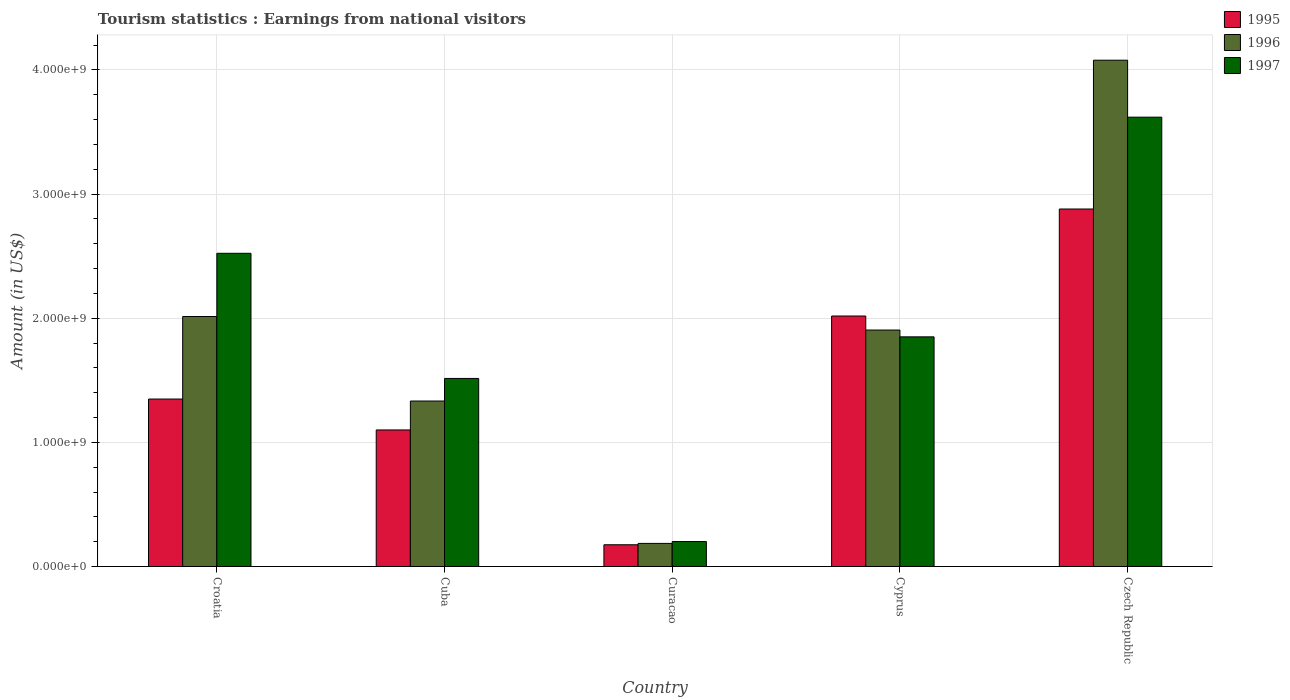How many groups of bars are there?
Your answer should be very brief. 5. Are the number of bars per tick equal to the number of legend labels?
Keep it short and to the point. Yes. How many bars are there on the 2nd tick from the right?
Make the answer very short. 3. What is the label of the 2nd group of bars from the left?
Your response must be concise. Cuba. What is the earnings from national visitors in 1997 in Croatia?
Your response must be concise. 2.52e+09. Across all countries, what is the maximum earnings from national visitors in 1997?
Keep it short and to the point. 3.62e+09. Across all countries, what is the minimum earnings from national visitors in 1996?
Offer a very short reply. 1.86e+08. In which country was the earnings from national visitors in 1995 maximum?
Ensure brevity in your answer.  Czech Republic. In which country was the earnings from national visitors in 1996 minimum?
Offer a very short reply. Curacao. What is the total earnings from national visitors in 1996 in the graph?
Offer a terse response. 9.52e+09. What is the difference between the earnings from national visitors in 1997 in Cuba and that in Cyprus?
Offer a terse response. -3.35e+08. What is the difference between the earnings from national visitors in 1997 in Cyprus and the earnings from national visitors in 1995 in Croatia?
Provide a succinct answer. 5.01e+08. What is the average earnings from national visitors in 1997 per country?
Give a very brief answer. 1.94e+09. What is the difference between the earnings from national visitors of/in 1997 and earnings from national visitors of/in 1996 in Cyprus?
Make the answer very short. -5.50e+07. What is the ratio of the earnings from national visitors in 1995 in Curacao to that in Czech Republic?
Provide a succinct answer. 0.06. Is the earnings from national visitors in 1995 in Croatia less than that in Cyprus?
Provide a succinct answer. Yes. What is the difference between the highest and the second highest earnings from national visitors in 1997?
Offer a very short reply. 1.10e+09. What is the difference between the highest and the lowest earnings from national visitors in 1996?
Give a very brief answer. 3.89e+09. In how many countries, is the earnings from national visitors in 1996 greater than the average earnings from national visitors in 1996 taken over all countries?
Your answer should be compact. 3. Is the sum of the earnings from national visitors in 1997 in Curacao and Cyprus greater than the maximum earnings from national visitors in 1995 across all countries?
Ensure brevity in your answer.  No. What does the 2nd bar from the left in Cuba represents?
Your response must be concise. 1996. What does the 1st bar from the right in Cyprus represents?
Keep it short and to the point. 1997. How many bars are there?
Your answer should be very brief. 15. How many countries are there in the graph?
Offer a very short reply. 5. How many legend labels are there?
Provide a short and direct response. 3. What is the title of the graph?
Your answer should be compact. Tourism statistics : Earnings from national visitors. What is the label or title of the X-axis?
Offer a very short reply. Country. What is the Amount (in US$) of 1995 in Croatia?
Make the answer very short. 1.35e+09. What is the Amount (in US$) of 1996 in Croatia?
Provide a succinct answer. 2.01e+09. What is the Amount (in US$) in 1997 in Croatia?
Your answer should be very brief. 2.52e+09. What is the Amount (in US$) in 1995 in Cuba?
Make the answer very short. 1.10e+09. What is the Amount (in US$) of 1996 in Cuba?
Ensure brevity in your answer.  1.33e+09. What is the Amount (in US$) of 1997 in Cuba?
Keep it short and to the point. 1.52e+09. What is the Amount (in US$) in 1995 in Curacao?
Your answer should be very brief. 1.75e+08. What is the Amount (in US$) in 1996 in Curacao?
Your answer should be compact. 1.86e+08. What is the Amount (in US$) in 1997 in Curacao?
Make the answer very short. 2.01e+08. What is the Amount (in US$) of 1995 in Cyprus?
Ensure brevity in your answer.  2.02e+09. What is the Amount (in US$) in 1996 in Cyprus?
Keep it short and to the point. 1.90e+09. What is the Amount (in US$) of 1997 in Cyprus?
Ensure brevity in your answer.  1.85e+09. What is the Amount (in US$) of 1995 in Czech Republic?
Keep it short and to the point. 2.88e+09. What is the Amount (in US$) of 1996 in Czech Republic?
Give a very brief answer. 4.08e+09. What is the Amount (in US$) in 1997 in Czech Republic?
Provide a succinct answer. 3.62e+09. Across all countries, what is the maximum Amount (in US$) of 1995?
Your answer should be very brief. 2.88e+09. Across all countries, what is the maximum Amount (in US$) of 1996?
Your answer should be compact. 4.08e+09. Across all countries, what is the maximum Amount (in US$) of 1997?
Offer a very short reply. 3.62e+09. Across all countries, what is the minimum Amount (in US$) of 1995?
Give a very brief answer. 1.75e+08. Across all countries, what is the minimum Amount (in US$) of 1996?
Offer a very short reply. 1.86e+08. Across all countries, what is the minimum Amount (in US$) in 1997?
Your response must be concise. 2.01e+08. What is the total Amount (in US$) of 1995 in the graph?
Make the answer very short. 7.52e+09. What is the total Amount (in US$) in 1996 in the graph?
Provide a succinct answer. 9.52e+09. What is the total Amount (in US$) of 1997 in the graph?
Your answer should be compact. 9.71e+09. What is the difference between the Amount (in US$) in 1995 in Croatia and that in Cuba?
Your answer should be compact. 2.49e+08. What is the difference between the Amount (in US$) of 1996 in Croatia and that in Cuba?
Give a very brief answer. 6.81e+08. What is the difference between the Amount (in US$) of 1997 in Croatia and that in Cuba?
Provide a succinct answer. 1.01e+09. What is the difference between the Amount (in US$) in 1995 in Croatia and that in Curacao?
Ensure brevity in your answer.  1.17e+09. What is the difference between the Amount (in US$) in 1996 in Croatia and that in Curacao?
Make the answer very short. 1.83e+09. What is the difference between the Amount (in US$) in 1997 in Croatia and that in Curacao?
Your answer should be compact. 2.32e+09. What is the difference between the Amount (in US$) of 1995 in Croatia and that in Cyprus?
Provide a short and direct response. -6.69e+08. What is the difference between the Amount (in US$) of 1996 in Croatia and that in Cyprus?
Offer a very short reply. 1.09e+08. What is the difference between the Amount (in US$) in 1997 in Croatia and that in Cyprus?
Your response must be concise. 6.73e+08. What is the difference between the Amount (in US$) of 1995 in Croatia and that in Czech Republic?
Your answer should be compact. -1.53e+09. What is the difference between the Amount (in US$) of 1996 in Croatia and that in Czech Republic?
Ensure brevity in your answer.  -2.06e+09. What is the difference between the Amount (in US$) in 1997 in Croatia and that in Czech Republic?
Give a very brief answer. -1.10e+09. What is the difference between the Amount (in US$) in 1995 in Cuba and that in Curacao?
Provide a succinct answer. 9.25e+08. What is the difference between the Amount (in US$) in 1996 in Cuba and that in Curacao?
Make the answer very short. 1.15e+09. What is the difference between the Amount (in US$) of 1997 in Cuba and that in Curacao?
Offer a very short reply. 1.31e+09. What is the difference between the Amount (in US$) of 1995 in Cuba and that in Cyprus?
Ensure brevity in your answer.  -9.18e+08. What is the difference between the Amount (in US$) of 1996 in Cuba and that in Cyprus?
Offer a terse response. -5.72e+08. What is the difference between the Amount (in US$) in 1997 in Cuba and that in Cyprus?
Offer a very short reply. -3.35e+08. What is the difference between the Amount (in US$) in 1995 in Cuba and that in Czech Republic?
Give a very brief answer. -1.78e+09. What is the difference between the Amount (in US$) in 1996 in Cuba and that in Czech Republic?
Ensure brevity in your answer.  -2.75e+09. What is the difference between the Amount (in US$) of 1997 in Cuba and that in Czech Republic?
Offer a very short reply. -2.10e+09. What is the difference between the Amount (in US$) of 1995 in Curacao and that in Cyprus?
Your response must be concise. -1.84e+09. What is the difference between the Amount (in US$) of 1996 in Curacao and that in Cyprus?
Your response must be concise. -1.72e+09. What is the difference between the Amount (in US$) in 1997 in Curacao and that in Cyprus?
Make the answer very short. -1.65e+09. What is the difference between the Amount (in US$) in 1995 in Curacao and that in Czech Republic?
Provide a short and direct response. -2.70e+09. What is the difference between the Amount (in US$) in 1996 in Curacao and that in Czech Republic?
Your response must be concise. -3.89e+09. What is the difference between the Amount (in US$) in 1997 in Curacao and that in Czech Republic?
Your response must be concise. -3.42e+09. What is the difference between the Amount (in US$) in 1995 in Cyprus and that in Czech Republic?
Your answer should be very brief. -8.62e+08. What is the difference between the Amount (in US$) of 1996 in Cyprus and that in Czech Republic?
Give a very brief answer. -2.17e+09. What is the difference between the Amount (in US$) of 1997 in Cyprus and that in Czech Republic?
Offer a very short reply. -1.77e+09. What is the difference between the Amount (in US$) in 1995 in Croatia and the Amount (in US$) in 1996 in Cuba?
Give a very brief answer. 1.60e+07. What is the difference between the Amount (in US$) of 1995 in Croatia and the Amount (in US$) of 1997 in Cuba?
Make the answer very short. -1.66e+08. What is the difference between the Amount (in US$) in 1996 in Croatia and the Amount (in US$) in 1997 in Cuba?
Provide a succinct answer. 4.99e+08. What is the difference between the Amount (in US$) of 1995 in Croatia and the Amount (in US$) of 1996 in Curacao?
Your response must be concise. 1.16e+09. What is the difference between the Amount (in US$) in 1995 in Croatia and the Amount (in US$) in 1997 in Curacao?
Your answer should be very brief. 1.15e+09. What is the difference between the Amount (in US$) of 1996 in Croatia and the Amount (in US$) of 1997 in Curacao?
Offer a terse response. 1.81e+09. What is the difference between the Amount (in US$) in 1995 in Croatia and the Amount (in US$) in 1996 in Cyprus?
Your answer should be compact. -5.56e+08. What is the difference between the Amount (in US$) in 1995 in Croatia and the Amount (in US$) in 1997 in Cyprus?
Give a very brief answer. -5.01e+08. What is the difference between the Amount (in US$) in 1996 in Croatia and the Amount (in US$) in 1997 in Cyprus?
Keep it short and to the point. 1.64e+08. What is the difference between the Amount (in US$) of 1995 in Croatia and the Amount (in US$) of 1996 in Czech Republic?
Your answer should be compact. -2.73e+09. What is the difference between the Amount (in US$) in 1995 in Croatia and the Amount (in US$) in 1997 in Czech Republic?
Ensure brevity in your answer.  -2.27e+09. What is the difference between the Amount (in US$) of 1996 in Croatia and the Amount (in US$) of 1997 in Czech Republic?
Offer a terse response. -1.61e+09. What is the difference between the Amount (in US$) in 1995 in Cuba and the Amount (in US$) in 1996 in Curacao?
Provide a short and direct response. 9.14e+08. What is the difference between the Amount (in US$) of 1995 in Cuba and the Amount (in US$) of 1997 in Curacao?
Provide a short and direct response. 8.99e+08. What is the difference between the Amount (in US$) in 1996 in Cuba and the Amount (in US$) in 1997 in Curacao?
Your answer should be compact. 1.13e+09. What is the difference between the Amount (in US$) in 1995 in Cuba and the Amount (in US$) in 1996 in Cyprus?
Ensure brevity in your answer.  -8.05e+08. What is the difference between the Amount (in US$) in 1995 in Cuba and the Amount (in US$) in 1997 in Cyprus?
Provide a succinct answer. -7.50e+08. What is the difference between the Amount (in US$) in 1996 in Cuba and the Amount (in US$) in 1997 in Cyprus?
Give a very brief answer. -5.17e+08. What is the difference between the Amount (in US$) of 1995 in Cuba and the Amount (in US$) of 1996 in Czech Republic?
Ensure brevity in your answer.  -2.98e+09. What is the difference between the Amount (in US$) in 1995 in Cuba and the Amount (in US$) in 1997 in Czech Republic?
Keep it short and to the point. -2.52e+09. What is the difference between the Amount (in US$) of 1996 in Cuba and the Amount (in US$) of 1997 in Czech Republic?
Give a very brief answer. -2.29e+09. What is the difference between the Amount (in US$) in 1995 in Curacao and the Amount (in US$) in 1996 in Cyprus?
Give a very brief answer. -1.73e+09. What is the difference between the Amount (in US$) in 1995 in Curacao and the Amount (in US$) in 1997 in Cyprus?
Your response must be concise. -1.68e+09. What is the difference between the Amount (in US$) in 1996 in Curacao and the Amount (in US$) in 1997 in Cyprus?
Your answer should be compact. -1.66e+09. What is the difference between the Amount (in US$) in 1995 in Curacao and the Amount (in US$) in 1996 in Czech Republic?
Your answer should be compact. -3.90e+09. What is the difference between the Amount (in US$) of 1995 in Curacao and the Amount (in US$) of 1997 in Czech Republic?
Give a very brief answer. -3.44e+09. What is the difference between the Amount (in US$) in 1996 in Curacao and the Amount (in US$) in 1997 in Czech Republic?
Offer a very short reply. -3.43e+09. What is the difference between the Amount (in US$) of 1995 in Cyprus and the Amount (in US$) of 1996 in Czech Republic?
Give a very brief answer. -2.06e+09. What is the difference between the Amount (in US$) of 1995 in Cyprus and the Amount (in US$) of 1997 in Czech Republic?
Provide a succinct answer. -1.60e+09. What is the difference between the Amount (in US$) in 1996 in Cyprus and the Amount (in US$) in 1997 in Czech Republic?
Provide a succinct answer. -1.72e+09. What is the average Amount (in US$) in 1995 per country?
Keep it short and to the point. 1.50e+09. What is the average Amount (in US$) in 1996 per country?
Provide a short and direct response. 1.90e+09. What is the average Amount (in US$) in 1997 per country?
Give a very brief answer. 1.94e+09. What is the difference between the Amount (in US$) of 1995 and Amount (in US$) of 1996 in Croatia?
Your answer should be compact. -6.65e+08. What is the difference between the Amount (in US$) in 1995 and Amount (in US$) in 1997 in Croatia?
Your answer should be compact. -1.17e+09. What is the difference between the Amount (in US$) in 1996 and Amount (in US$) in 1997 in Croatia?
Make the answer very short. -5.09e+08. What is the difference between the Amount (in US$) of 1995 and Amount (in US$) of 1996 in Cuba?
Keep it short and to the point. -2.33e+08. What is the difference between the Amount (in US$) of 1995 and Amount (in US$) of 1997 in Cuba?
Your answer should be compact. -4.15e+08. What is the difference between the Amount (in US$) of 1996 and Amount (in US$) of 1997 in Cuba?
Provide a short and direct response. -1.82e+08. What is the difference between the Amount (in US$) in 1995 and Amount (in US$) in 1996 in Curacao?
Offer a very short reply. -1.10e+07. What is the difference between the Amount (in US$) in 1995 and Amount (in US$) in 1997 in Curacao?
Give a very brief answer. -2.60e+07. What is the difference between the Amount (in US$) of 1996 and Amount (in US$) of 1997 in Curacao?
Keep it short and to the point. -1.50e+07. What is the difference between the Amount (in US$) in 1995 and Amount (in US$) in 1996 in Cyprus?
Your answer should be compact. 1.13e+08. What is the difference between the Amount (in US$) of 1995 and Amount (in US$) of 1997 in Cyprus?
Your response must be concise. 1.68e+08. What is the difference between the Amount (in US$) in 1996 and Amount (in US$) in 1997 in Cyprus?
Provide a short and direct response. 5.50e+07. What is the difference between the Amount (in US$) of 1995 and Amount (in US$) of 1996 in Czech Republic?
Your answer should be very brief. -1.20e+09. What is the difference between the Amount (in US$) of 1995 and Amount (in US$) of 1997 in Czech Republic?
Keep it short and to the point. -7.40e+08. What is the difference between the Amount (in US$) of 1996 and Amount (in US$) of 1997 in Czech Republic?
Make the answer very short. 4.59e+08. What is the ratio of the Amount (in US$) of 1995 in Croatia to that in Cuba?
Offer a very short reply. 1.23. What is the ratio of the Amount (in US$) of 1996 in Croatia to that in Cuba?
Give a very brief answer. 1.51. What is the ratio of the Amount (in US$) in 1997 in Croatia to that in Cuba?
Offer a terse response. 1.67. What is the ratio of the Amount (in US$) of 1995 in Croatia to that in Curacao?
Your response must be concise. 7.71. What is the ratio of the Amount (in US$) of 1996 in Croatia to that in Curacao?
Your response must be concise. 10.83. What is the ratio of the Amount (in US$) in 1997 in Croatia to that in Curacao?
Give a very brief answer. 12.55. What is the ratio of the Amount (in US$) in 1995 in Croatia to that in Cyprus?
Provide a short and direct response. 0.67. What is the ratio of the Amount (in US$) of 1996 in Croatia to that in Cyprus?
Give a very brief answer. 1.06. What is the ratio of the Amount (in US$) of 1997 in Croatia to that in Cyprus?
Offer a terse response. 1.36. What is the ratio of the Amount (in US$) of 1995 in Croatia to that in Czech Republic?
Make the answer very short. 0.47. What is the ratio of the Amount (in US$) in 1996 in Croatia to that in Czech Republic?
Ensure brevity in your answer.  0.49. What is the ratio of the Amount (in US$) of 1997 in Croatia to that in Czech Republic?
Your answer should be compact. 0.7. What is the ratio of the Amount (in US$) of 1995 in Cuba to that in Curacao?
Provide a succinct answer. 6.29. What is the ratio of the Amount (in US$) in 1996 in Cuba to that in Curacao?
Your answer should be compact. 7.17. What is the ratio of the Amount (in US$) in 1997 in Cuba to that in Curacao?
Offer a very short reply. 7.54. What is the ratio of the Amount (in US$) in 1995 in Cuba to that in Cyprus?
Your response must be concise. 0.55. What is the ratio of the Amount (in US$) in 1996 in Cuba to that in Cyprus?
Provide a short and direct response. 0.7. What is the ratio of the Amount (in US$) of 1997 in Cuba to that in Cyprus?
Give a very brief answer. 0.82. What is the ratio of the Amount (in US$) of 1995 in Cuba to that in Czech Republic?
Your answer should be compact. 0.38. What is the ratio of the Amount (in US$) in 1996 in Cuba to that in Czech Republic?
Provide a succinct answer. 0.33. What is the ratio of the Amount (in US$) of 1997 in Cuba to that in Czech Republic?
Keep it short and to the point. 0.42. What is the ratio of the Amount (in US$) of 1995 in Curacao to that in Cyprus?
Your answer should be very brief. 0.09. What is the ratio of the Amount (in US$) of 1996 in Curacao to that in Cyprus?
Provide a succinct answer. 0.1. What is the ratio of the Amount (in US$) of 1997 in Curacao to that in Cyprus?
Keep it short and to the point. 0.11. What is the ratio of the Amount (in US$) in 1995 in Curacao to that in Czech Republic?
Provide a succinct answer. 0.06. What is the ratio of the Amount (in US$) in 1996 in Curacao to that in Czech Republic?
Provide a succinct answer. 0.05. What is the ratio of the Amount (in US$) of 1997 in Curacao to that in Czech Republic?
Ensure brevity in your answer.  0.06. What is the ratio of the Amount (in US$) in 1995 in Cyprus to that in Czech Republic?
Provide a short and direct response. 0.7. What is the ratio of the Amount (in US$) of 1996 in Cyprus to that in Czech Republic?
Provide a short and direct response. 0.47. What is the ratio of the Amount (in US$) in 1997 in Cyprus to that in Czech Republic?
Offer a very short reply. 0.51. What is the difference between the highest and the second highest Amount (in US$) in 1995?
Give a very brief answer. 8.62e+08. What is the difference between the highest and the second highest Amount (in US$) of 1996?
Your answer should be very brief. 2.06e+09. What is the difference between the highest and the second highest Amount (in US$) in 1997?
Your answer should be very brief. 1.10e+09. What is the difference between the highest and the lowest Amount (in US$) in 1995?
Ensure brevity in your answer.  2.70e+09. What is the difference between the highest and the lowest Amount (in US$) of 1996?
Your answer should be compact. 3.89e+09. What is the difference between the highest and the lowest Amount (in US$) of 1997?
Your answer should be very brief. 3.42e+09. 